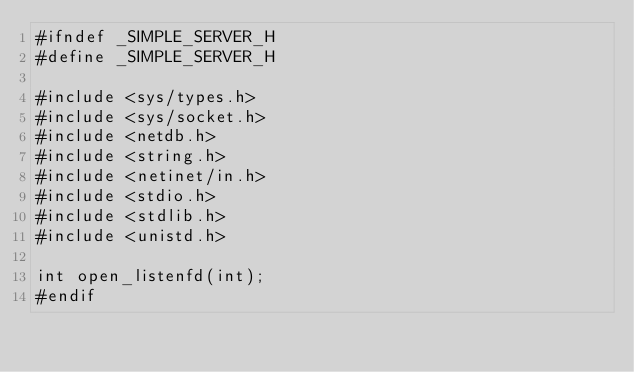Convert code to text. <code><loc_0><loc_0><loc_500><loc_500><_C_>#ifndef _SIMPLE_SERVER_H
#define _SIMPLE_SERVER_H

#include <sys/types.h>
#include <sys/socket.h>
#include <netdb.h>
#include <string.h>
#include <netinet/in.h>
#include <stdio.h>
#include <stdlib.h>
#include <unistd.h>

int open_listenfd(int);
#endif
</code> 